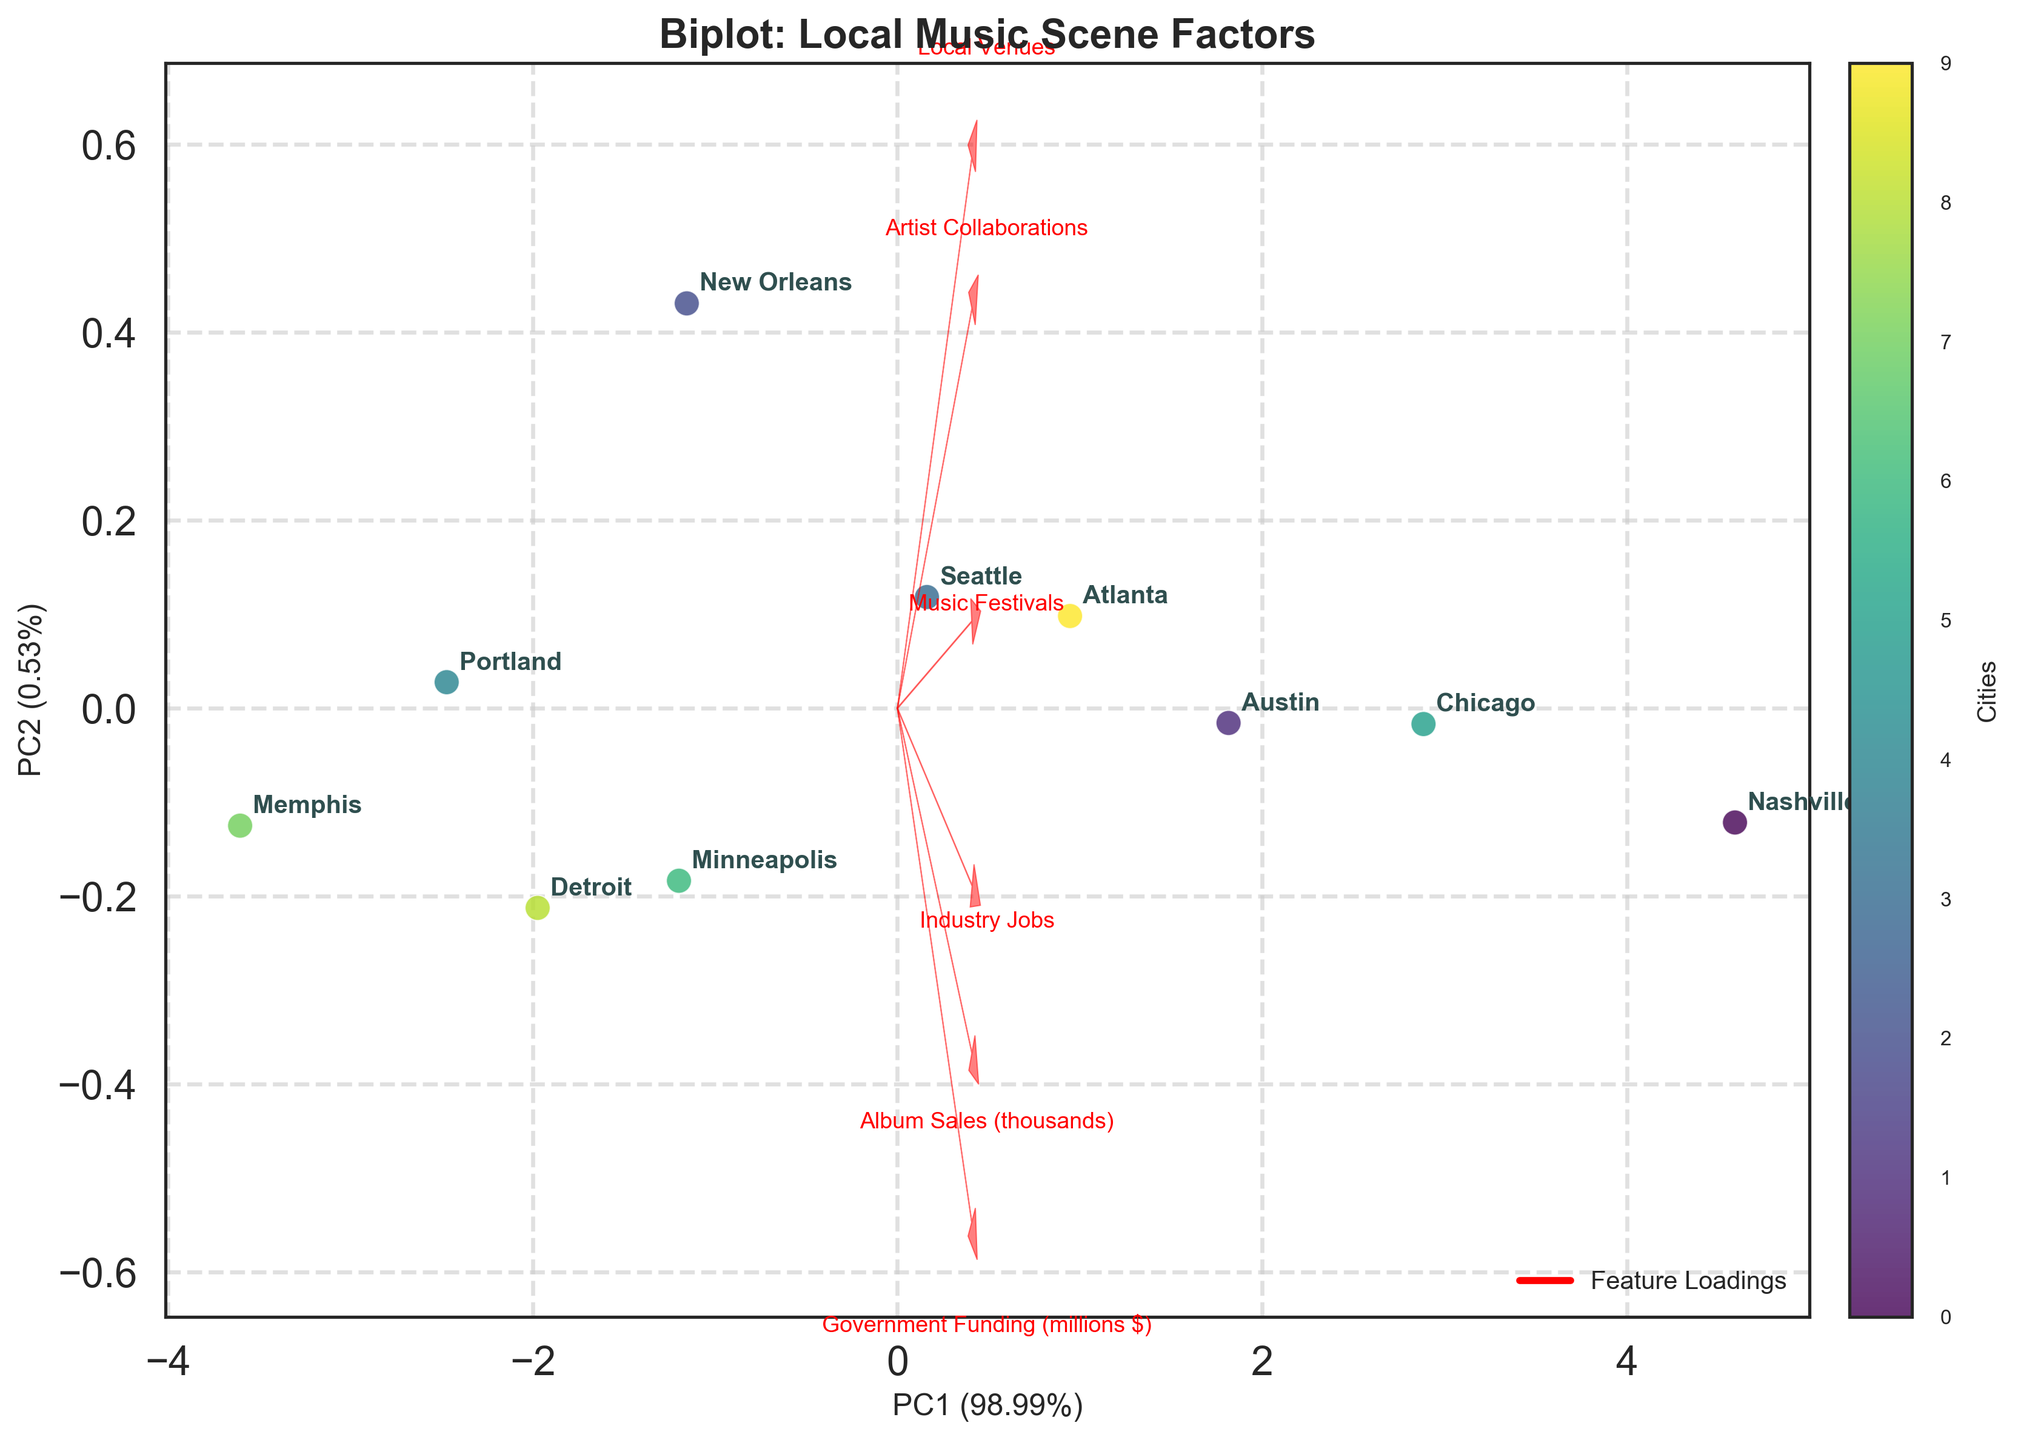What is the title of the plot? The title is usually displayed at the top of the figure. It summarizes the main topic or what the plot is about.
Answer: Biplot: Local Music Scene Factors How many cities are represented in the plot? There are multiple annotations on the plot, each representing a different city. By counting these annotations, we can determine the number of cities.
Answer: 10 Which city is closest to the origin of the plot? The origin of the plot is the point (0,0). By identifying the city annotation closest to this point, we find our answer.
Answer: Memphis Which features have the largest component values on PC1? Arrows representing features point in various directions. The features with arrows that extend farthest along the PC1 axis have the largest component values on PC1.
Answer: Government Funding (millions $) and Local Venues Which city has the highest value on PC1? The PC1 axis is the horizontal axis. By identifying which city's point is the farthest to the right on this axis, we can determine the city with the highest value on PC1.
Answer: Nashville How do the values of Government Funding (millions $) and Industry Jobs compare between Austin and Chicago? We look at Austin and Chicago's positions relative to the arrows representing Government Funding and Industry Jobs. By comparing their distances along these directions, we can see their relative values. Government Funding is roughly similar for both, but Chicago is slightly higher. Similarly, Industry Jobs are slightly higher in Chicago.
Answer: Chicago is slightly higher in both What percentage of the variance is explained by PC1 and PC2 together? The x-axis and y-axis labels provide the explained variance percentage for PC1 and PC2 respectively. Adding these percentages gives the total explained variance by both components.
Answer: About 63.5% Which city has the most balanced influence across the features? A city point close to the origin indicates that it has relatively balanced or moderate values across all features. We can identify this city by finding the one closest to the origin.
Answer: Memphis Which feature contributes most strongly towards separating Minneapolis from Nashville? Compare the directions of feature arrows with the line connecting the points for Minneapolis and Nashville. The feature whose arrow is most aligned with this line contributes most strongly.
Answer: Government Funding (millions $) Is there a correlation between the number of Music Festivals and Album Sales? By examining the direction of the arrows for Music Festivals and Album Sales, we can see if they point in a similar direction, indicating a positive correlation. The arrows are relatively aligned, suggesting a correlation.
Answer: Yes 